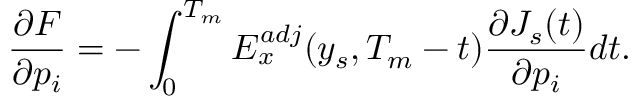Convert formula to latex. <formula><loc_0><loc_0><loc_500><loc_500>\frac { \partial F } { \partial p _ { i } } = - \int _ { 0 } ^ { T _ { m } } E _ { x } ^ { a d j } ( y _ { s } , T _ { m } - t ) \frac { \partial J _ { s } ( t ) } { \partial p _ { i } } d t .</formula> 